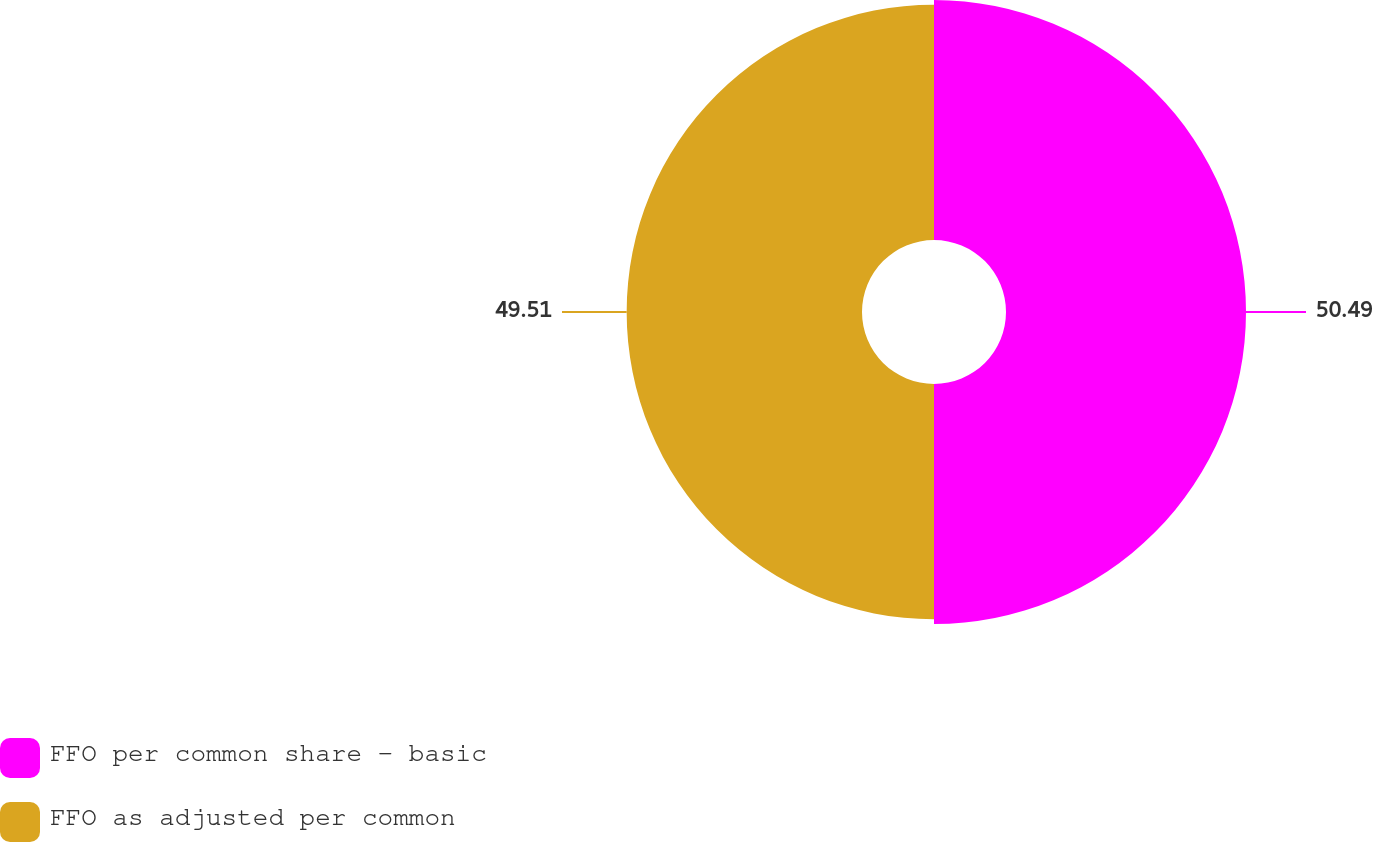Convert chart to OTSL. <chart><loc_0><loc_0><loc_500><loc_500><pie_chart><fcel>FFO per common share - basic<fcel>FFO as adjusted per common<nl><fcel>50.49%<fcel>49.51%<nl></chart> 